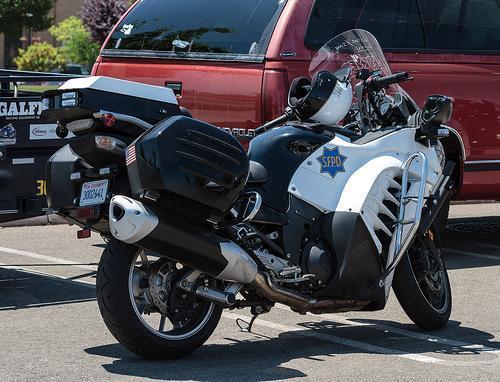How many vehicles are in the parking lot picture?
Give a very brief answer. 2. 